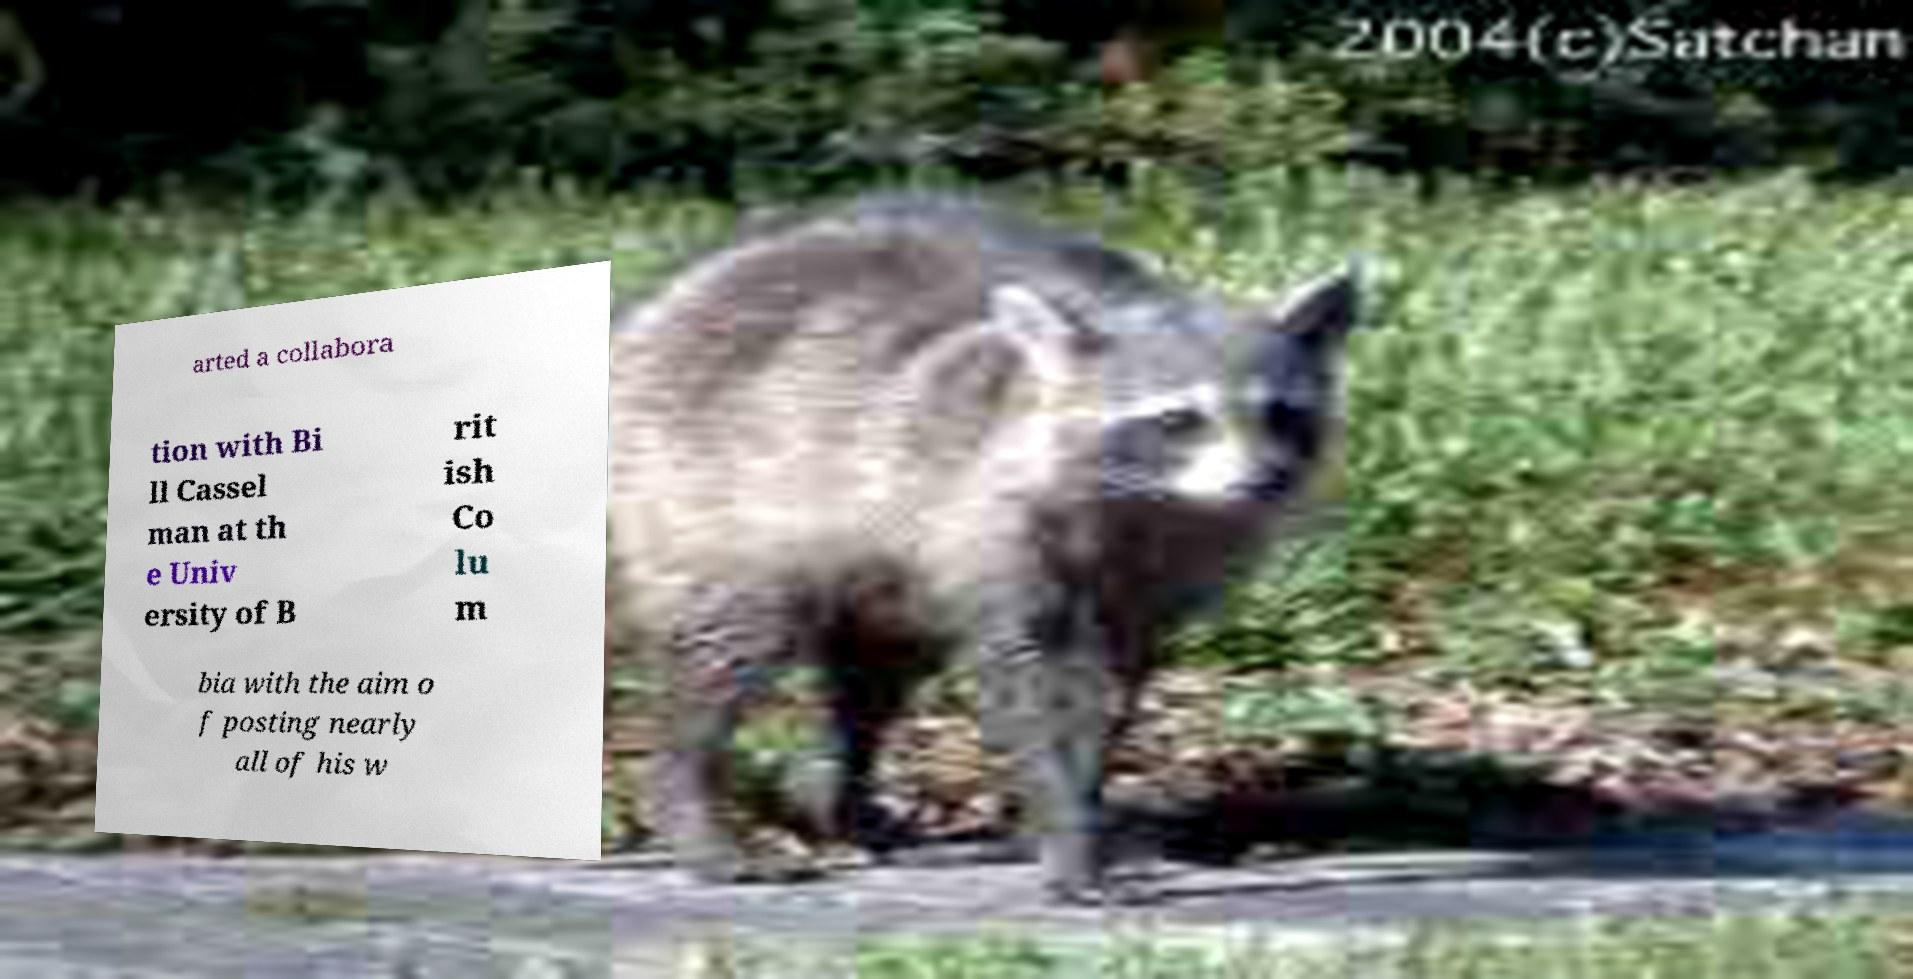For documentation purposes, I need the text within this image transcribed. Could you provide that? arted a collabora tion with Bi ll Cassel man at th e Univ ersity of B rit ish Co lu m bia with the aim o f posting nearly all of his w 